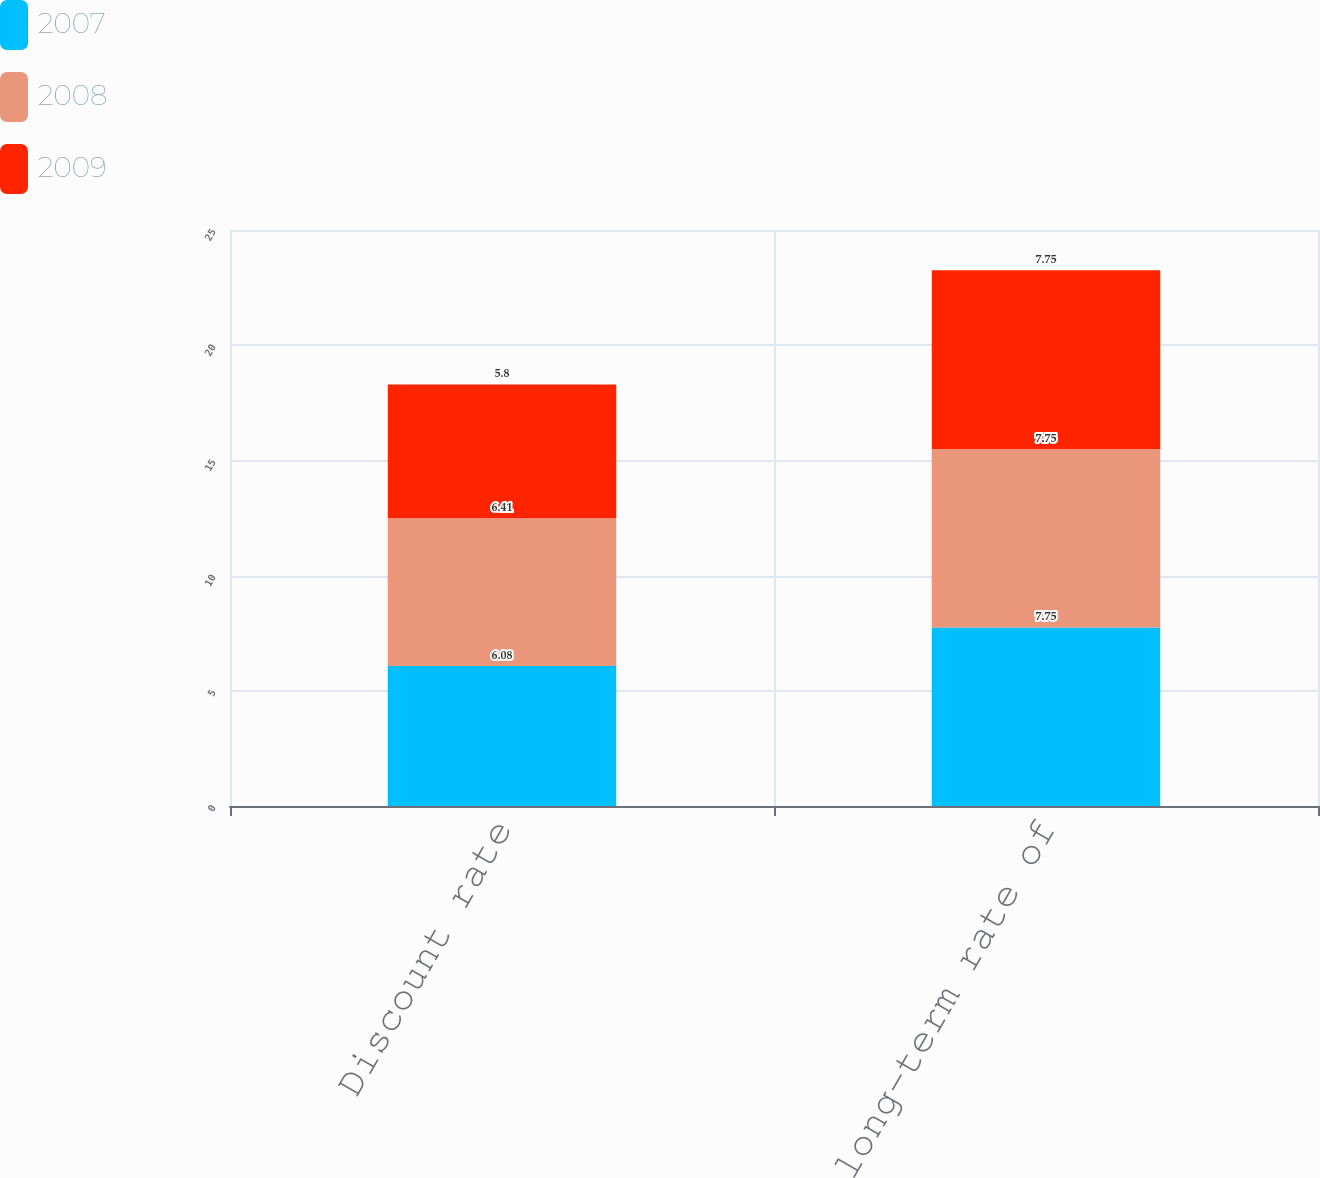<chart> <loc_0><loc_0><loc_500><loc_500><stacked_bar_chart><ecel><fcel>Discount rate<fcel>Expected long-term rate of<nl><fcel>2007<fcel>6.08<fcel>7.75<nl><fcel>2008<fcel>6.41<fcel>7.75<nl><fcel>2009<fcel>5.8<fcel>7.75<nl></chart> 